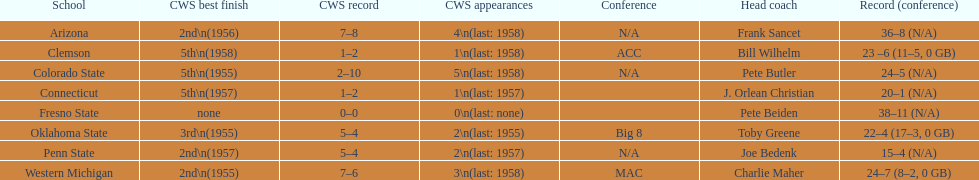Which team did not have more than 16 wins? Penn State. 